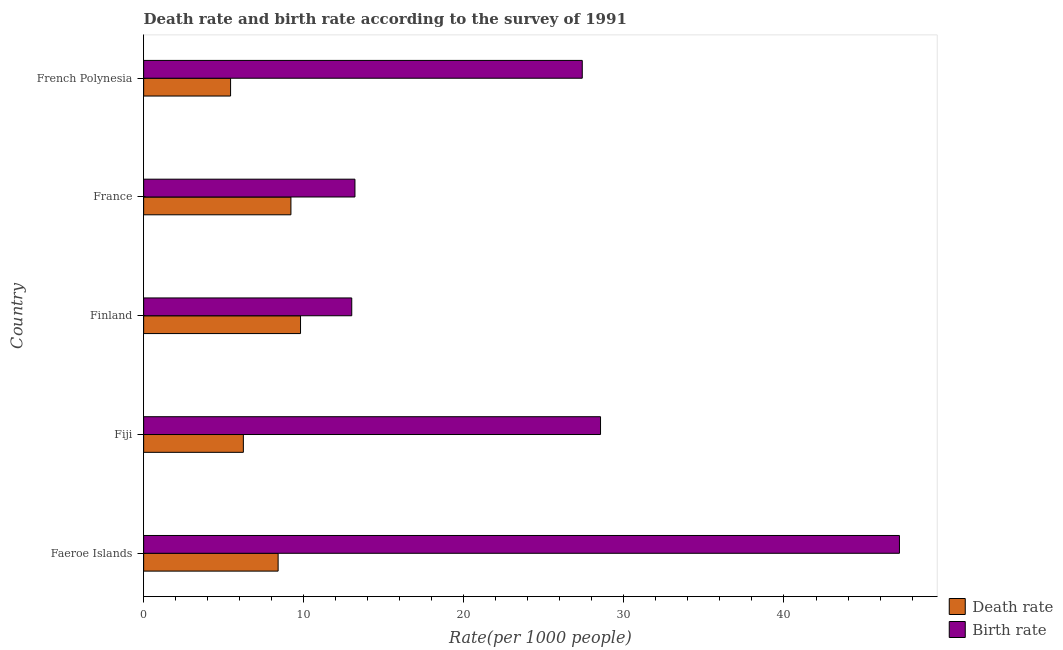How many different coloured bars are there?
Your answer should be compact. 2. Are the number of bars per tick equal to the number of legend labels?
Provide a succinct answer. Yes. Are the number of bars on each tick of the Y-axis equal?
Your response must be concise. Yes. How many bars are there on the 2nd tick from the bottom?
Provide a succinct answer. 2. What is the label of the 1st group of bars from the top?
Offer a terse response. French Polynesia. In how many cases, is the number of bars for a given country not equal to the number of legend labels?
Offer a terse response. 0. What is the birth rate in Faeroe Islands?
Your response must be concise. 47.21. Across all countries, what is the maximum birth rate?
Keep it short and to the point. 47.21. Across all countries, what is the minimum death rate?
Your response must be concise. 5.43. In which country was the birth rate maximum?
Your answer should be compact. Faeroe Islands. In which country was the birth rate minimum?
Give a very brief answer. Finland. What is the total birth rate in the graph?
Provide a short and direct response. 129.35. What is the difference between the birth rate in Faeroe Islands and that in Fiji?
Ensure brevity in your answer.  18.67. What is the difference between the birth rate in Fiji and the death rate in French Polynesia?
Provide a succinct answer. 23.11. What is the average birth rate per country?
Provide a succinct answer. 25.87. What is the difference between the death rate and birth rate in French Polynesia?
Give a very brief answer. -21.97. What is the ratio of the death rate in Fiji to that in French Polynesia?
Your answer should be compact. 1.15. Is the difference between the birth rate in Faeroe Islands and Fiji greater than the difference between the death rate in Faeroe Islands and Fiji?
Offer a terse response. Yes. What is the difference between the highest and the second highest birth rate?
Give a very brief answer. 18.67. What is the difference between the highest and the lowest death rate?
Make the answer very short. 4.37. What does the 2nd bar from the top in France represents?
Provide a short and direct response. Death rate. What does the 1st bar from the bottom in Finland represents?
Offer a terse response. Death rate. How many bars are there?
Offer a very short reply. 10. Are all the bars in the graph horizontal?
Give a very brief answer. Yes. What is the difference between two consecutive major ticks on the X-axis?
Your answer should be compact. 10. Does the graph contain grids?
Offer a very short reply. No. Where does the legend appear in the graph?
Make the answer very short. Bottom right. How are the legend labels stacked?
Give a very brief answer. Vertical. What is the title of the graph?
Make the answer very short. Death rate and birth rate according to the survey of 1991. What is the label or title of the X-axis?
Your answer should be compact. Rate(per 1000 people). What is the Rate(per 1000 people) in Death rate in Faeroe Islands?
Keep it short and to the point. 8.4. What is the Rate(per 1000 people) in Birth rate in Faeroe Islands?
Ensure brevity in your answer.  47.21. What is the Rate(per 1000 people) of Death rate in Fiji?
Ensure brevity in your answer.  6.23. What is the Rate(per 1000 people) in Birth rate in Fiji?
Give a very brief answer. 28.54. What is the Rate(per 1000 people) of Death rate in Finland?
Provide a succinct answer. 9.8. What is the Rate(per 1000 people) of Birth rate in Finland?
Ensure brevity in your answer.  13. What is the Rate(per 1000 people) in Death rate in France?
Keep it short and to the point. 9.2. What is the Rate(per 1000 people) of Birth rate in France?
Offer a terse response. 13.2. What is the Rate(per 1000 people) in Death rate in French Polynesia?
Make the answer very short. 5.43. What is the Rate(per 1000 people) in Birth rate in French Polynesia?
Provide a short and direct response. 27.4. Across all countries, what is the maximum Rate(per 1000 people) in Death rate?
Offer a very short reply. 9.8. Across all countries, what is the maximum Rate(per 1000 people) in Birth rate?
Offer a very short reply. 47.21. Across all countries, what is the minimum Rate(per 1000 people) of Death rate?
Keep it short and to the point. 5.43. Across all countries, what is the minimum Rate(per 1000 people) in Birth rate?
Your response must be concise. 13. What is the total Rate(per 1000 people) of Death rate in the graph?
Give a very brief answer. 39.06. What is the total Rate(per 1000 people) of Birth rate in the graph?
Your response must be concise. 129.35. What is the difference between the Rate(per 1000 people) of Death rate in Faeroe Islands and that in Fiji?
Your answer should be very brief. 2.17. What is the difference between the Rate(per 1000 people) of Birth rate in Faeroe Islands and that in Fiji?
Offer a terse response. 18.67. What is the difference between the Rate(per 1000 people) in Death rate in Faeroe Islands and that in Finland?
Ensure brevity in your answer.  -1.4. What is the difference between the Rate(per 1000 people) of Birth rate in Faeroe Islands and that in Finland?
Make the answer very short. 34.21. What is the difference between the Rate(per 1000 people) in Birth rate in Faeroe Islands and that in France?
Provide a succinct answer. 34.01. What is the difference between the Rate(per 1000 people) in Death rate in Faeroe Islands and that in French Polynesia?
Your answer should be compact. 2.97. What is the difference between the Rate(per 1000 people) of Birth rate in Faeroe Islands and that in French Polynesia?
Your answer should be compact. 19.81. What is the difference between the Rate(per 1000 people) in Death rate in Fiji and that in Finland?
Your answer should be very brief. -3.57. What is the difference between the Rate(per 1000 people) of Birth rate in Fiji and that in Finland?
Provide a succinct answer. 15.54. What is the difference between the Rate(per 1000 people) of Death rate in Fiji and that in France?
Keep it short and to the point. -2.97. What is the difference between the Rate(per 1000 people) in Birth rate in Fiji and that in France?
Your answer should be compact. 15.34. What is the difference between the Rate(per 1000 people) in Death rate in Fiji and that in French Polynesia?
Your response must be concise. 0.8. What is the difference between the Rate(per 1000 people) in Birth rate in Fiji and that in French Polynesia?
Offer a very short reply. 1.14. What is the difference between the Rate(per 1000 people) in Death rate in Finland and that in French Polynesia?
Your response must be concise. 4.37. What is the difference between the Rate(per 1000 people) in Birth rate in Finland and that in French Polynesia?
Provide a short and direct response. -14.4. What is the difference between the Rate(per 1000 people) of Death rate in France and that in French Polynesia?
Your response must be concise. 3.77. What is the difference between the Rate(per 1000 people) of Birth rate in France and that in French Polynesia?
Offer a very short reply. -14.2. What is the difference between the Rate(per 1000 people) of Death rate in Faeroe Islands and the Rate(per 1000 people) of Birth rate in Fiji?
Provide a short and direct response. -20.14. What is the difference between the Rate(per 1000 people) of Death rate in Faeroe Islands and the Rate(per 1000 people) of Birth rate in French Polynesia?
Ensure brevity in your answer.  -19. What is the difference between the Rate(per 1000 people) in Death rate in Fiji and the Rate(per 1000 people) in Birth rate in Finland?
Your answer should be very brief. -6.77. What is the difference between the Rate(per 1000 people) of Death rate in Fiji and the Rate(per 1000 people) of Birth rate in France?
Provide a short and direct response. -6.97. What is the difference between the Rate(per 1000 people) in Death rate in Fiji and the Rate(per 1000 people) in Birth rate in French Polynesia?
Provide a short and direct response. -21.17. What is the difference between the Rate(per 1000 people) of Death rate in Finland and the Rate(per 1000 people) of Birth rate in France?
Your answer should be very brief. -3.4. What is the difference between the Rate(per 1000 people) of Death rate in Finland and the Rate(per 1000 people) of Birth rate in French Polynesia?
Keep it short and to the point. -17.6. What is the difference between the Rate(per 1000 people) of Death rate in France and the Rate(per 1000 people) of Birth rate in French Polynesia?
Ensure brevity in your answer.  -18.2. What is the average Rate(per 1000 people) in Death rate per country?
Make the answer very short. 7.81. What is the average Rate(per 1000 people) of Birth rate per country?
Provide a succinct answer. 25.87. What is the difference between the Rate(per 1000 people) of Death rate and Rate(per 1000 people) of Birth rate in Faeroe Islands?
Offer a terse response. -38.81. What is the difference between the Rate(per 1000 people) in Death rate and Rate(per 1000 people) in Birth rate in Fiji?
Keep it short and to the point. -22.31. What is the difference between the Rate(per 1000 people) of Death rate and Rate(per 1000 people) of Birth rate in Finland?
Keep it short and to the point. -3.2. What is the difference between the Rate(per 1000 people) of Death rate and Rate(per 1000 people) of Birth rate in France?
Your answer should be very brief. -4. What is the difference between the Rate(per 1000 people) of Death rate and Rate(per 1000 people) of Birth rate in French Polynesia?
Make the answer very short. -21.97. What is the ratio of the Rate(per 1000 people) in Death rate in Faeroe Islands to that in Fiji?
Your answer should be very brief. 1.35. What is the ratio of the Rate(per 1000 people) of Birth rate in Faeroe Islands to that in Fiji?
Keep it short and to the point. 1.65. What is the ratio of the Rate(per 1000 people) of Death rate in Faeroe Islands to that in Finland?
Ensure brevity in your answer.  0.86. What is the ratio of the Rate(per 1000 people) of Birth rate in Faeroe Islands to that in Finland?
Offer a very short reply. 3.63. What is the ratio of the Rate(per 1000 people) of Birth rate in Faeroe Islands to that in France?
Make the answer very short. 3.58. What is the ratio of the Rate(per 1000 people) in Death rate in Faeroe Islands to that in French Polynesia?
Provide a succinct answer. 1.55. What is the ratio of the Rate(per 1000 people) in Birth rate in Faeroe Islands to that in French Polynesia?
Offer a very short reply. 1.72. What is the ratio of the Rate(per 1000 people) of Death rate in Fiji to that in Finland?
Your response must be concise. 0.64. What is the ratio of the Rate(per 1000 people) of Birth rate in Fiji to that in Finland?
Offer a terse response. 2.2. What is the ratio of the Rate(per 1000 people) of Death rate in Fiji to that in France?
Give a very brief answer. 0.68. What is the ratio of the Rate(per 1000 people) of Birth rate in Fiji to that in France?
Offer a very short reply. 2.16. What is the ratio of the Rate(per 1000 people) in Death rate in Fiji to that in French Polynesia?
Provide a succinct answer. 1.15. What is the ratio of the Rate(per 1000 people) in Birth rate in Fiji to that in French Polynesia?
Offer a very short reply. 1.04. What is the ratio of the Rate(per 1000 people) of Death rate in Finland to that in France?
Your answer should be compact. 1.07. What is the ratio of the Rate(per 1000 people) in Death rate in Finland to that in French Polynesia?
Your answer should be very brief. 1.8. What is the ratio of the Rate(per 1000 people) of Birth rate in Finland to that in French Polynesia?
Give a very brief answer. 0.47. What is the ratio of the Rate(per 1000 people) in Death rate in France to that in French Polynesia?
Your answer should be very brief. 1.69. What is the ratio of the Rate(per 1000 people) in Birth rate in France to that in French Polynesia?
Provide a succinct answer. 0.48. What is the difference between the highest and the second highest Rate(per 1000 people) in Death rate?
Your response must be concise. 0.6. What is the difference between the highest and the second highest Rate(per 1000 people) in Birth rate?
Provide a succinct answer. 18.67. What is the difference between the highest and the lowest Rate(per 1000 people) of Death rate?
Offer a very short reply. 4.37. What is the difference between the highest and the lowest Rate(per 1000 people) in Birth rate?
Make the answer very short. 34.21. 